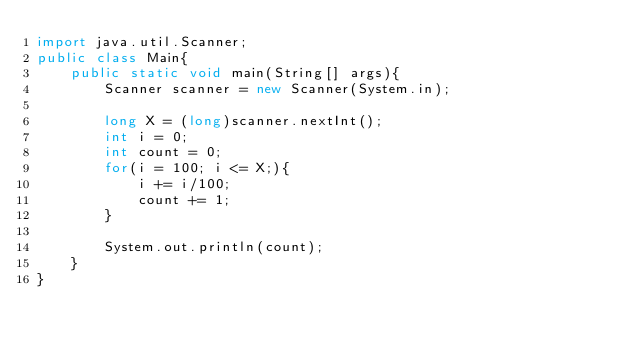<code> <loc_0><loc_0><loc_500><loc_500><_Java_>import java.util.Scanner;
public class Main{
    public static void main(String[] args){
        Scanner scanner = new Scanner(System.in);
        
        long X = (long)scanner.nextInt();
        int i = 0;
        int count = 0;
        for(i = 100; i <= X;){
            i += i/100;
            count += 1;
        }

        System.out.println(count);
    }
}</code> 